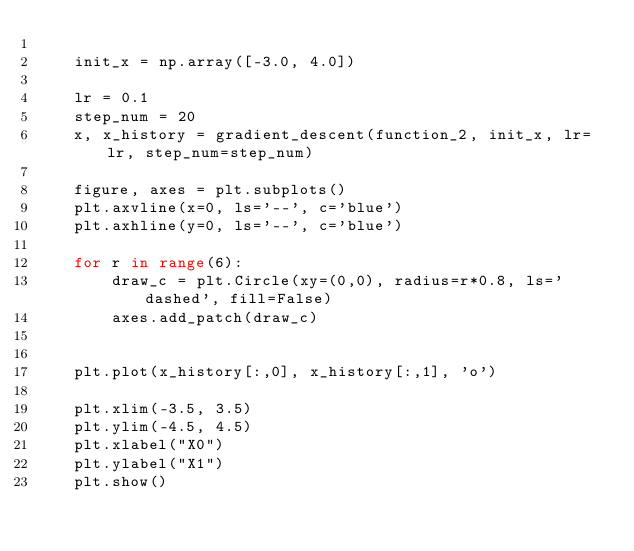<code> <loc_0><loc_0><loc_500><loc_500><_Python_>    
    init_x = np.array([-3.0, 4.0])    

    lr = 0.1
    step_num = 20
    x, x_history = gradient_descent(function_2, init_x, lr=lr, step_num=step_num)
    
    figure, axes = plt.subplots()
    plt.axvline(x=0, ls='--', c='blue')
    plt.axhline(y=0, ls='--', c='blue')
    
    for r in range(6):
        draw_c = plt.Circle(xy=(0,0), radius=r*0.8, ls='dashed', fill=False)
        axes.add_patch(draw_c)
        
        
    plt.plot(x_history[:,0], x_history[:,1], 'o')
    
    plt.xlim(-3.5, 3.5)
    plt.ylim(-4.5, 4.5)
    plt.xlabel("X0")
    plt.ylabel("X1")
    plt.show()

</code> 